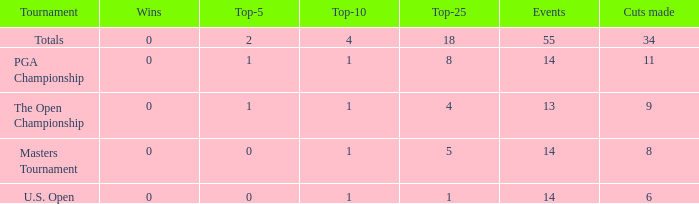What is the average top-10 when the cuts made is less than 9 and the events is more than 14? None. 